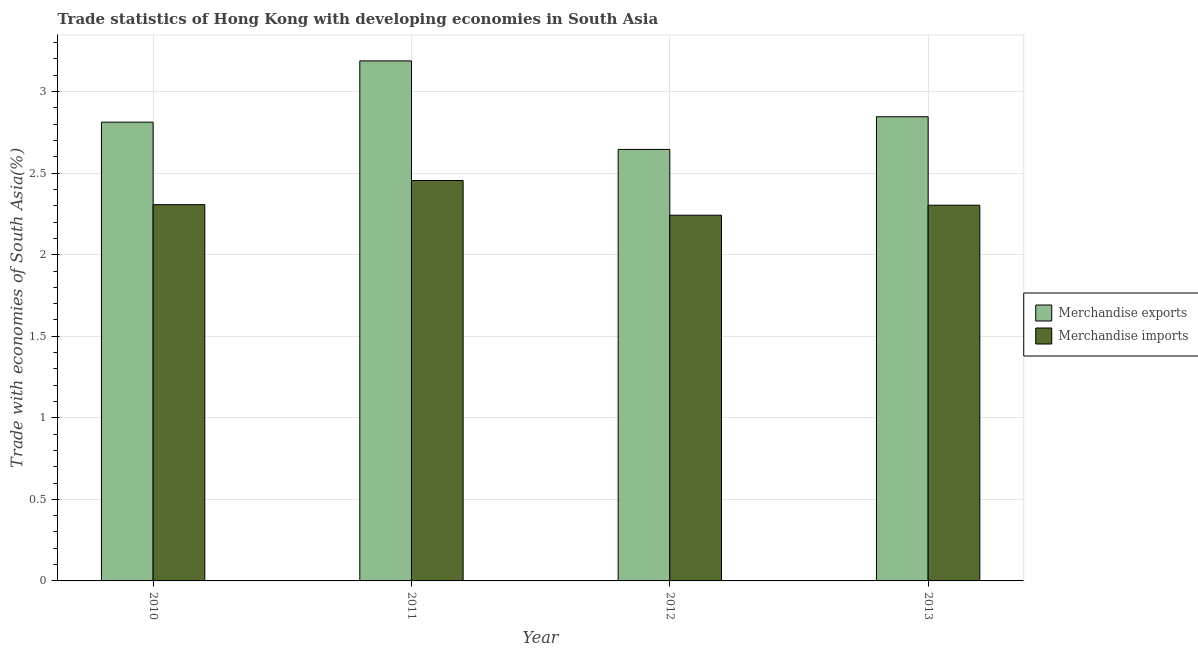Are the number of bars per tick equal to the number of legend labels?
Make the answer very short. Yes. Are the number of bars on each tick of the X-axis equal?
Your answer should be compact. Yes. What is the label of the 4th group of bars from the left?
Your response must be concise. 2013. What is the merchandise imports in 2012?
Provide a succinct answer. 2.24. Across all years, what is the maximum merchandise exports?
Offer a very short reply. 3.19. Across all years, what is the minimum merchandise exports?
Keep it short and to the point. 2.65. In which year was the merchandise imports minimum?
Your response must be concise. 2012. What is the total merchandise imports in the graph?
Your response must be concise. 9.31. What is the difference between the merchandise imports in 2010 and that in 2013?
Provide a succinct answer. 0. What is the difference between the merchandise imports in 2012 and the merchandise exports in 2010?
Offer a very short reply. -0.06. What is the average merchandise exports per year?
Make the answer very short. 2.87. In the year 2013, what is the difference between the merchandise exports and merchandise imports?
Your answer should be very brief. 0. What is the ratio of the merchandise exports in 2011 to that in 2012?
Ensure brevity in your answer.  1.21. Is the merchandise exports in 2011 less than that in 2012?
Make the answer very short. No. Is the difference between the merchandise imports in 2010 and 2012 greater than the difference between the merchandise exports in 2010 and 2012?
Offer a very short reply. No. What is the difference between the highest and the second highest merchandise exports?
Your answer should be compact. 0.34. What is the difference between the highest and the lowest merchandise imports?
Ensure brevity in your answer.  0.21. Is the sum of the merchandise imports in 2010 and 2012 greater than the maximum merchandise exports across all years?
Keep it short and to the point. Yes. Where does the legend appear in the graph?
Ensure brevity in your answer.  Center right. What is the title of the graph?
Make the answer very short. Trade statistics of Hong Kong with developing economies in South Asia. Does "Lowest 20% of population" appear as one of the legend labels in the graph?
Your answer should be compact. No. What is the label or title of the Y-axis?
Provide a succinct answer. Trade with economies of South Asia(%). What is the Trade with economies of South Asia(%) of Merchandise exports in 2010?
Offer a very short reply. 2.81. What is the Trade with economies of South Asia(%) in Merchandise imports in 2010?
Ensure brevity in your answer.  2.31. What is the Trade with economies of South Asia(%) of Merchandise exports in 2011?
Offer a very short reply. 3.19. What is the Trade with economies of South Asia(%) of Merchandise imports in 2011?
Give a very brief answer. 2.45. What is the Trade with economies of South Asia(%) of Merchandise exports in 2012?
Give a very brief answer. 2.65. What is the Trade with economies of South Asia(%) in Merchandise imports in 2012?
Provide a succinct answer. 2.24. What is the Trade with economies of South Asia(%) of Merchandise exports in 2013?
Ensure brevity in your answer.  2.85. What is the Trade with economies of South Asia(%) of Merchandise imports in 2013?
Ensure brevity in your answer.  2.3. Across all years, what is the maximum Trade with economies of South Asia(%) of Merchandise exports?
Make the answer very short. 3.19. Across all years, what is the maximum Trade with economies of South Asia(%) of Merchandise imports?
Make the answer very short. 2.45. Across all years, what is the minimum Trade with economies of South Asia(%) of Merchandise exports?
Keep it short and to the point. 2.65. Across all years, what is the minimum Trade with economies of South Asia(%) of Merchandise imports?
Offer a terse response. 2.24. What is the total Trade with economies of South Asia(%) of Merchandise exports in the graph?
Make the answer very short. 11.49. What is the total Trade with economies of South Asia(%) in Merchandise imports in the graph?
Your response must be concise. 9.31. What is the difference between the Trade with economies of South Asia(%) of Merchandise exports in 2010 and that in 2011?
Ensure brevity in your answer.  -0.38. What is the difference between the Trade with economies of South Asia(%) of Merchandise imports in 2010 and that in 2011?
Offer a terse response. -0.15. What is the difference between the Trade with economies of South Asia(%) in Merchandise exports in 2010 and that in 2012?
Provide a short and direct response. 0.17. What is the difference between the Trade with economies of South Asia(%) in Merchandise imports in 2010 and that in 2012?
Your response must be concise. 0.06. What is the difference between the Trade with economies of South Asia(%) in Merchandise exports in 2010 and that in 2013?
Offer a terse response. -0.03. What is the difference between the Trade with economies of South Asia(%) of Merchandise imports in 2010 and that in 2013?
Make the answer very short. 0. What is the difference between the Trade with economies of South Asia(%) in Merchandise exports in 2011 and that in 2012?
Give a very brief answer. 0.54. What is the difference between the Trade with economies of South Asia(%) in Merchandise imports in 2011 and that in 2012?
Provide a succinct answer. 0.21. What is the difference between the Trade with economies of South Asia(%) in Merchandise exports in 2011 and that in 2013?
Provide a succinct answer. 0.34. What is the difference between the Trade with economies of South Asia(%) in Merchandise imports in 2011 and that in 2013?
Your response must be concise. 0.15. What is the difference between the Trade with economies of South Asia(%) of Merchandise exports in 2012 and that in 2013?
Give a very brief answer. -0.2. What is the difference between the Trade with economies of South Asia(%) in Merchandise imports in 2012 and that in 2013?
Your response must be concise. -0.06. What is the difference between the Trade with economies of South Asia(%) in Merchandise exports in 2010 and the Trade with economies of South Asia(%) in Merchandise imports in 2011?
Your answer should be compact. 0.36. What is the difference between the Trade with economies of South Asia(%) in Merchandise exports in 2010 and the Trade with economies of South Asia(%) in Merchandise imports in 2012?
Your response must be concise. 0.57. What is the difference between the Trade with economies of South Asia(%) of Merchandise exports in 2010 and the Trade with economies of South Asia(%) of Merchandise imports in 2013?
Keep it short and to the point. 0.51. What is the difference between the Trade with economies of South Asia(%) in Merchandise exports in 2011 and the Trade with economies of South Asia(%) in Merchandise imports in 2012?
Give a very brief answer. 0.95. What is the difference between the Trade with economies of South Asia(%) of Merchandise exports in 2011 and the Trade with economies of South Asia(%) of Merchandise imports in 2013?
Your answer should be compact. 0.88. What is the difference between the Trade with economies of South Asia(%) in Merchandise exports in 2012 and the Trade with economies of South Asia(%) in Merchandise imports in 2013?
Offer a very short reply. 0.34. What is the average Trade with economies of South Asia(%) in Merchandise exports per year?
Keep it short and to the point. 2.87. What is the average Trade with economies of South Asia(%) of Merchandise imports per year?
Your answer should be compact. 2.33. In the year 2010, what is the difference between the Trade with economies of South Asia(%) of Merchandise exports and Trade with economies of South Asia(%) of Merchandise imports?
Your answer should be very brief. 0.51. In the year 2011, what is the difference between the Trade with economies of South Asia(%) of Merchandise exports and Trade with economies of South Asia(%) of Merchandise imports?
Your answer should be very brief. 0.73. In the year 2012, what is the difference between the Trade with economies of South Asia(%) of Merchandise exports and Trade with economies of South Asia(%) of Merchandise imports?
Ensure brevity in your answer.  0.4. In the year 2013, what is the difference between the Trade with economies of South Asia(%) of Merchandise exports and Trade with economies of South Asia(%) of Merchandise imports?
Keep it short and to the point. 0.54. What is the ratio of the Trade with economies of South Asia(%) of Merchandise exports in 2010 to that in 2011?
Your response must be concise. 0.88. What is the ratio of the Trade with economies of South Asia(%) in Merchandise imports in 2010 to that in 2011?
Your response must be concise. 0.94. What is the ratio of the Trade with economies of South Asia(%) in Merchandise exports in 2010 to that in 2012?
Offer a very short reply. 1.06. What is the ratio of the Trade with economies of South Asia(%) of Merchandise imports in 2010 to that in 2012?
Give a very brief answer. 1.03. What is the ratio of the Trade with economies of South Asia(%) in Merchandise exports in 2010 to that in 2013?
Provide a short and direct response. 0.99. What is the ratio of the Trade with economies of South Asia(%) of Merchandise imports in 2010 to that in 2013?
Provide a succinct answer. 1. What is the ratio of the Trade with economies of South Asia(%) in Merchandise exports in 2011 to that in 2012?
Your answer should be compact. 1.21. What is the ratio of the Trade with economies of South Asia(%) of Merchandise imports in 2011 to that in 2012?
Give a very brief answer. 1.09. What is the ratio of the Trade with economies of South Asia(%) in Merchandise exports in 2011 to that in 2013?
Provide a succinct answer. 1.12. What is the ratio of the Trade with economies of South Asia(%) in Merchandise imports in 2011 to that in 2013?
Offer a terse response. 1.07. What is the ratio of the Trade with economies of South Asia(%) of Merchandise exports in 2012 to that in 2013?
Your answer should be compact. 0.93. What is the ratio of the Trade with economies of South Asia(%) of Merchandise imports in 2012 to that in 2013?
Offer a very short reply. 0.97. What is the difference between the highest and the second highest Trade with economies of South Asia(%) of Merchandise exports?
Provide a succinct answer. 0.34. What is the difference between the highest and the second highest Trade with economies of South Asia(%) in Merchandise imports?
Provide a short and direct response. 0.15. What is the difference between the highest and the lowest Trade with economies of South Asia(%) of Merchandise exports?
Your answer should be very brief. 0.54. What is the difference between the highest and the lowest Trade with economies of South Asia(%) of Merchandise imports?
Your answer should be very brief. 0.21. 